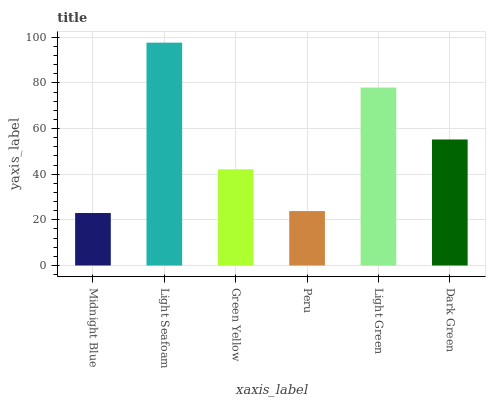Is Green Yellow the minimum?
Answer yes or no. No. Is Green Yellow the maximum?
Answer yes or no. No. Is Light Seafoam greater than Green Yellow?
Answer yes or no. Yes. Is Green Yellow less than Light Seafoam?
Answer yes or no. Yes. Is Green Yellow greater than Light Seafoam?
Answer yes or no. No. Is Light Seafoam less than Green Yellow?
Answer yes or no. No. Is Dark Green the high median?
Answer yes or no. Yes. Is Green Yellow the low median?
Answer yes or no. Yes. Is Light Green the high median?
Answer yes or no. No. Is Light Green the low median?
Answer yes or no. No. 